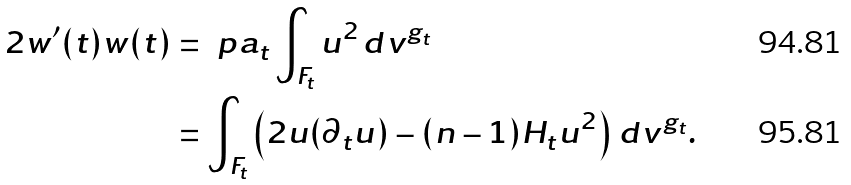<formula> <loc_0><loc_0><loc_500><loc_500>2 w ^ { \prime } ( t ) w ( t ) & = \ p a _ { t } \int _ { F _ { t } } u ^ { 2 } \, d v ^ { g _ { t } } \\ & = \int _ { F _ { t } } \left ( 2 u ( \partial _ { t } u ) - ( n - 1 ) H _ { t } u ^ { 2 } \right ) \, d v ^ { g _ { t } } .</formula> 